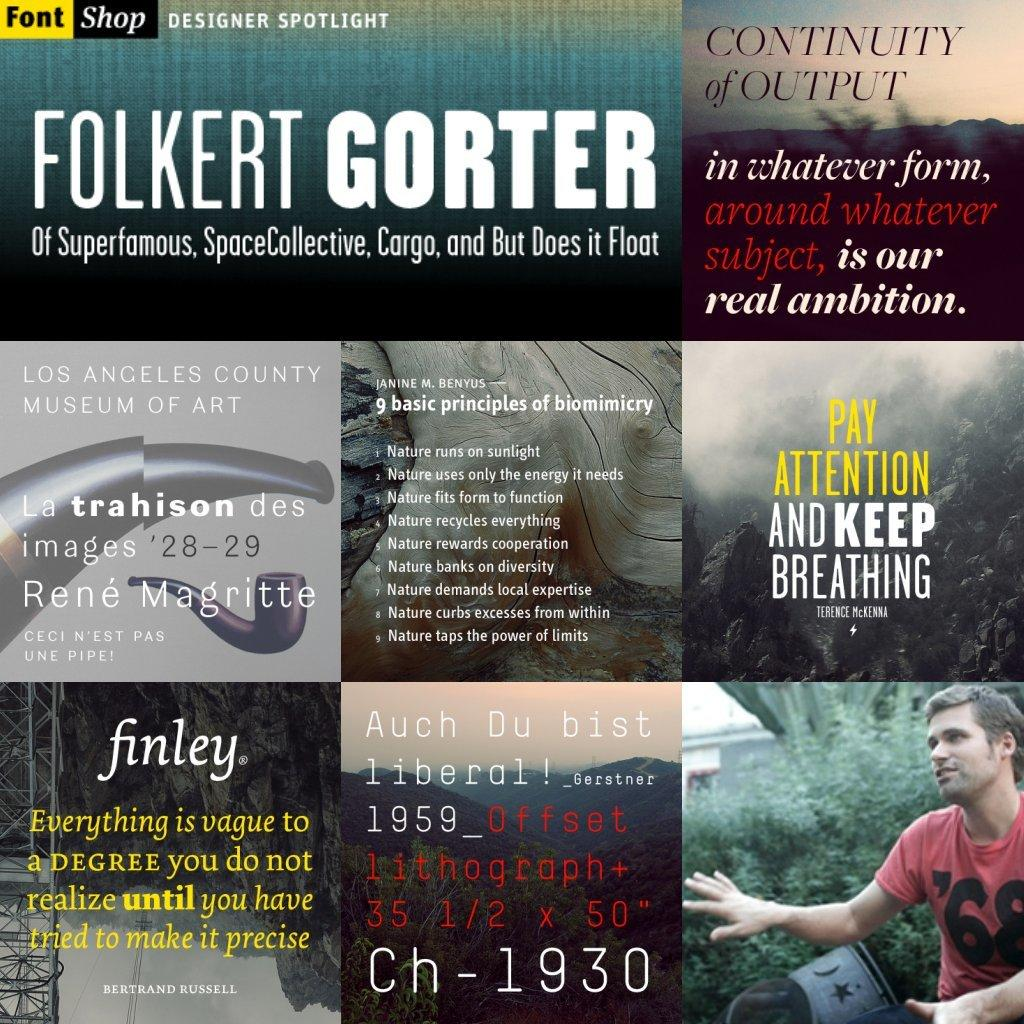What type of image is being described? The image is a collage. What can be found within the collage? There are pictures of persons in the collage. Are there any words or phrases in the collage? Yes, there is text in the collage. How many boats are visible in the collage? There are no boats present in the collage; it features pictures of persons and text. What type of tooth is being displayed in the collage? There is no tooth present in the collage; it consists of pictures of persons and text. 